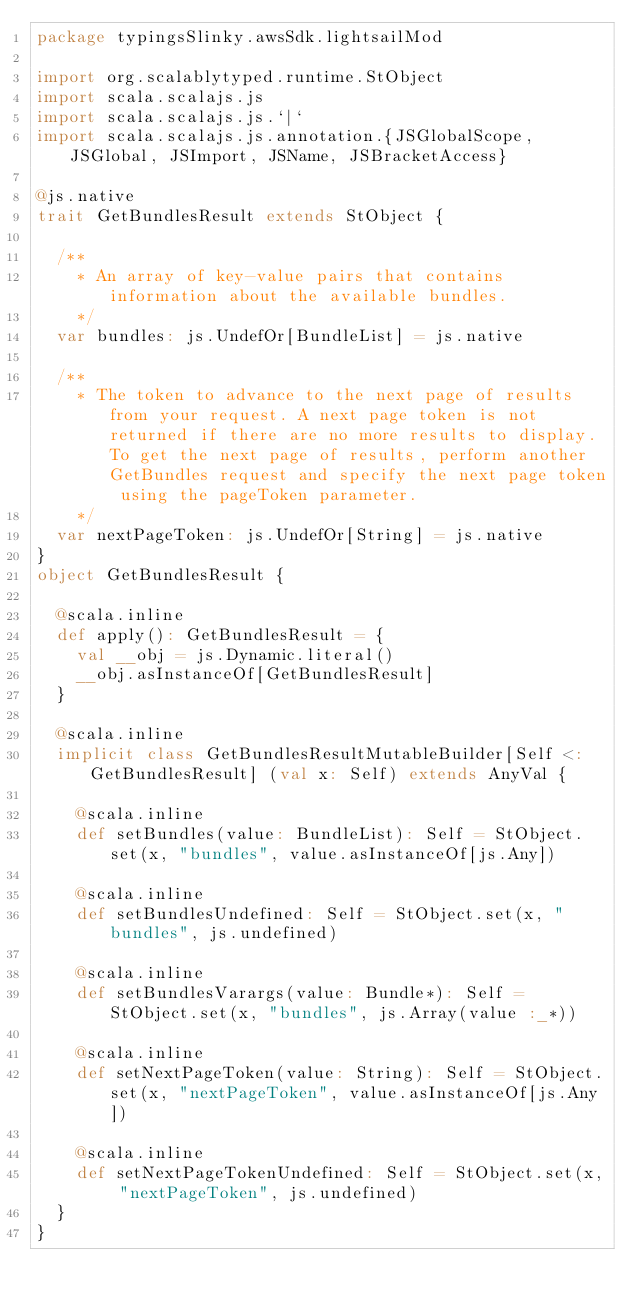Convert code to text. <code><loc_0><loc_0><loc_500><loc_500><_Scala_>package typingsSlinky.awsSdk.lightsailMod

import org.scalablytyped.runtime.StObject
import scala.scalajs.js
import scala.scalajs.js.`|`
import scala.scalajs.js.annotation.{JSGlobalScope, JSGlobal, JSImport, JSName, JSBracketAccess}

@js.native
trait GetBundlesResult extends StObject {
  
  /**
    * An array of key-value pairs that contains information about the available bundles.
    */
  var bundles: js.UndefOr[BundleList] = js.native
  
  /**
    * The token to advance to the next page of results from your request. A next page token is not returned if there are no more results to display. To get the next page of results, perform another GetBundles request and specify the next page token using the pageToken parameter.
    */
  var nextPageToken: js.UndefOr[String] = js.native
}
object GetBundlesResult {
  
  @scala.inline
  def apply(): GetBundlesResult = {
    val __obj = js.Dynamic.literal()
    __obj.asInstanceOf[GetBundlesResult]
  }
  
  @scala.inline
  implicit class GetBundlesResultMutableBuilder[Self <: GetBundlesResult] (val x: Self) extends AnyVal {
    
    @scala.inline
    def setBundles(value: BundleList): Self = StObject.set(x, "bundles", value.asInstanceOf[js.Any])
    
    @scala.inline
    def setBundlesUndefined: Self = StObject.set(x, "bundles", js.undefined)
    
    @scala.inline
    def setBundlesVarargs(value: Bundle*): Self = StObject.set(x, "bundles", js.Array(value :_*))
    
    @scala.inline
    def setNextPageToken(value: String): Self = StObject.set(x, "nextPageToken", value.asInstanceOf[js.Any])
    
    @scala.inline
    def setNextPageTokenUndefined: Self = StObject.set(x, "nextPageToken", js.undefined)
  }
}
</code> 